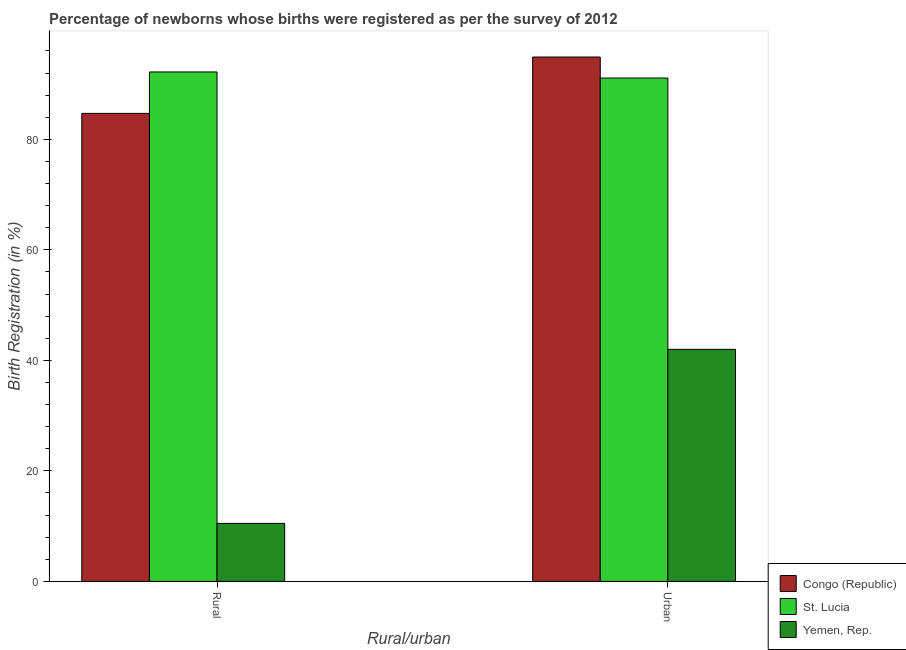How many different coloured bars are there?
Your answer should be compact. 3. Are the number of bars on each tick of the X-axis equal?
Your answer should be compact. Yes. How many bars are there on the 2nd tick from the right?
Your answer should be very brief. 3. What is the label of the 2nd group of bars from the left?
Give a very brief answer. Urban. What is the rural birth registration in Congo (Republic)?
Provide a succinct answer. 84.7. Across all countries, what is the maximum urban birth registration?
Your answer should be compact. 94.9. Across all countries, what is the minimum urban birth registration?
Your answer should be very brief. 42. In which country was the urban birth registration maximum?
Give a very brief answer. Congo (Republic). In which country was the urban birth registration minimum?
Your answer should be compact. Yemen, Rep. What is the total rural birth registration in the graph?
Provide a succinct answer. 187.4. What is the difference between the urban birth registration in St. Lucia and that in Yemen, Rep.?
Your response must be concise. 49.1. What is the difference between the urban birth registration in Congo (Republic) and the rural birth registration in St. Lucia?
Your answer should be very brief. 2.7. What is the average urban birth registration per country?
Provide a succinct answer. 76. What is the difference between the urban birth registration and rural birth registration in Yemen, Rep.?
Provide a succinct answer. 31.5. In how many countries, is the urban birth registration greater than 52 %?
Your answer should be compact. 2. What is the ratio of the urban birth registration in Yemen, Rep. to that in St. Lucia?
Your answer should be compact. 0.46. What does the 1st bar from the left in Rural represents?
Your response must be concise. Congo (Republic). What does the 2nd bar from the right in Urban represents?
Provide a short and direct response. St. Lucia. How many bars are there?
Your response must be concise. 6. Are all the bars in the graph horizontal?
Your answer should be compact. No. Does the graph contain any zero values?
Offer a terse response. No. Does the graph contain grids?
Offer a terse response. No. How many legend labels are there?
Provide a succinct answer. 3. What is the title of the graph?
Provide a succinct answer. Percentage of newborns whose births were registered as per the survey of 2012. What is the label or title of the X-axis?
Your answer should be compact. Rural/urban. What is the label or title of the Y-axis?
Provide a succinct answer. Birth Registration (in %). What is the Birth Registration (in %) of Congo (Republic) in Rural?
Make the answer very short. 84.7. What is the Birth Registration (in %) in St. Lucia in Rural?
Provide a succinct answer. 92.2. What is the Birth Registration (in %) in Yemen, Rep. in Rural?
Give a very brief answer. 10.5. What is the Birth Registration (in %) of Congo (Republic) in Urban?
Offer a terse response. 94.9. What is the Birth Registration (in %) in St. Lucia in Urban?
Ensure brevity in your answer.  91.1. What is the Birth Registration (in %) of Yemen, Rep. in Urban?
Provide a succinct answer. 42. Across all Rural/urban, what is the maximum Birth Registration (in %) in Congo (Republic)?
Ensure brevity in your answer.  94.9. Across all Rural/urban, what is the maximum Birth Registration (in %) of St. Lucia?
Offer a terse response. 92.2. Across all Rural/urban, what is the minimum Birth Registration (in %) in Congo (Republic)?
Offer a terse response. 84.7. Across all Rural/urban, what is the minimum Birth Registration (in %) in St. Lucia?
Offer a very short reply. 91.1. What is the total Birth Registration (in %) in Congo (Republic) in the graph?
Ensure brevity in your answer.  179.6. What is the total Birth Registration (in %) in St. Lucia in the graph?
Make the answer very short. 183.3. What is the total Birth Registration (in %) in Yemen, Rep. in the graph?
Make the answer very short. 52.5. What is the difference between the Birth Registration (in %) in Congo (Republic) in Rural and that in Urban?
Your answer should be compact. -10.2. What is the difference between the Birth Registration (in %) in Yemen, Rep. in Rural and that in Urban?
Provide a succinct answer. -31.5. What is the difference between the Birth Registration (in %) in Congo (Republic) in Rural and the Birth Registration (in %) in St. Lucia in Urban?
Your answer should be compact. -6.4. What is the difference between the Birth Registration (in %) in Congo (Republic) in Rural and the Birth Registration (in %) in Yemen, Rep. in Urban?
Ensure brevity in your answer.  42.7. What is the difference between the Birth Registration (in %) of St. Lucia in Rural and the Birth Registration (in %) of Yemen, Rep. in Urban?
Provide a succinct answer. 50.2. What is the average Birth Registration (in %) in Congo (Republic) per Rural/urban?
Offer a terse response. 89.8. What is the average Birth Registration (in %) in St. Lucia per Rural/urban?
Your answer should be very brief. 91.65. What is the average Birth Registration (in %) in Yemen, Rep. per Rural/urban?
Give a very brief answer. 26.25. What is the difference between the Birth Registration (in %) in Congo (Republic) and Birth Registration (in %) in St. Lucia in Rural?
Give a very brief answer. -7.5. What is the difference between the Birth Registration (in %) in Congo (Republic) and Birth Registration (in %) in Yemen, Rep. in Rural?
Provide a short and direct response. 74.2. What is the difference between the Birth Registration (in %) in St. Lucia and Birth Registration (in %) in Yemen, Rep. in Rural?
Make the answer very short. 81.7. What is the difference between the Birth Registration (in %) of Congo (Republic) and Birth Registration (in %) of St. Lucia in Urban?
Give a very brief answer. 3.8. What is the difference between the Birth Registration (in %) of Congo (Republic) and Birth Registration (in %) of Yemen, Rep. in Urban?
Make the answer very short. 52.9. What is the difference between the Birth Registration (in %) in St. Lucia and Birth Registration (in %) in Yemen, Rep. in Urban?
Your response must be concise. 49.1. What is the ratio of the Birth Registration (in %) in Congo (Republic) in Rural to that in Urban?
Give a very brief answer. 0.89. What is the ratio of the Birth Registration (in %) in St. Lucia in Rural to that in Urban?
Your response must be concise. 1.01. What is the ratio of the Birth Registration (in %) of Yemen, Rep. in Rural to that in Urban?
Your answer should be compact. 0.25. What is the difference between the highest and the second highest Birth Registration (in %) of Yemen, Rep.?
Ensure brevity in your answer.  31.5. What is the difference between the highest and the lowest Birth Registration (in %) of Congo (Republic)?
Keep it short and to the point. 10.2. What is the difference between the highest and the lowest Birth Registration (in %) in Yemen, Rep.?
Provide a short and direct response. 31.5. 